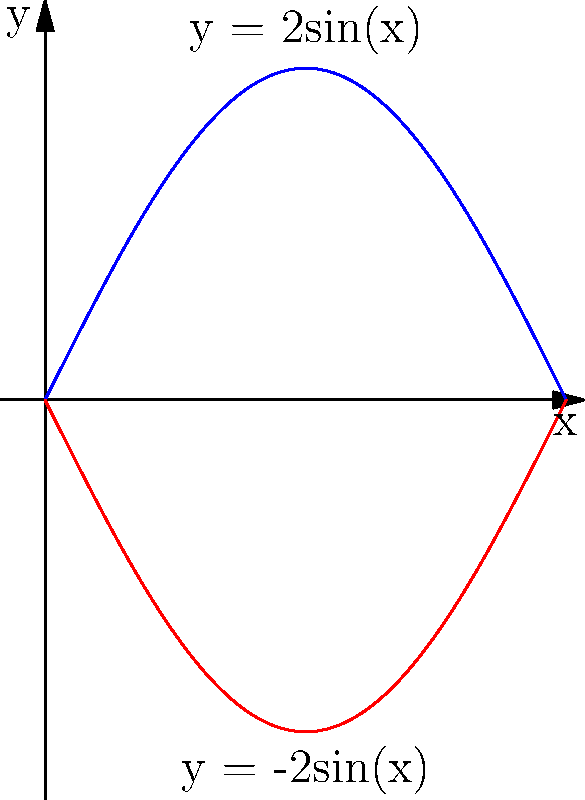A dancer's graceful movement on stage traces a curve that can be described by the function $y = 2\sin(x)$ from $x = 0$ to $x = \pi$. The dancer's reflection on the stage floor traces the curve $y = -2\sin(x)$ over the same interval. Calculate the area enclosed between these two curves, representing the total space covered by the dancer's performance. How might this area inform your description of the dancer's presence and impact on stage in your book? To find the area between the two curves, we need to integrate the difference between the upper and lower functions over the given interval. Here's how we can approach this:

1) The upper curve is $y_1 = 2\sin(x)$
2) The lower curve is $y_2 = -2\sin(x)$
3) The area between the curves is given by:

   $$A = \int_0^\pi (y_1 - y_2) dx = \int_0^\pi (2\sin(x) - (-2\sin(x))) dx$$

4) Simplify the integrand:

   $$A = \int_0^\pi (2\sin(x) + 2\sin(x)) dx = \int_0^\pi 4\sin(x) dx$$

5) Integrate:

   $$A = -4\cos(x) \Big|_0^\pi$$

6) Evaluate the integral:

   $$A = [-4\cos(\pi)] - [-4\cos(0)] = -4(-1) - (-4) = 4 + 4 = 8$$

Therefore, the area enclosed between the two curves is 8 square units.

This area represents the total space covered by the dancer's movement and its reflection, symbolizing the dancer's presence and impact on stage. In your book, you could use this to describe how the dancer's performance fills and transforms the space, creating a dynamic volume of motion that captivates the audience.
Answer: 8 square units 